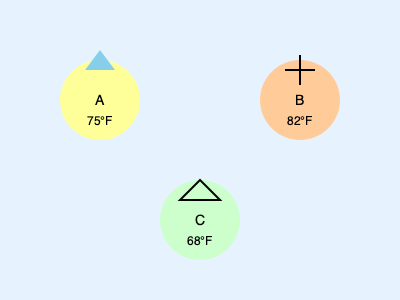Looking at this cheerful weather map, which city is most likely to have the perfect conditions for a sunny picnic with your fellow recruits? Let's break down the weather conditions for each city with a smile:

1. City A (100, 100):
   - Temperature: 75°F (quite pleasant!)
   - Weather icon: Raindrop shape (looks like it might rain)
   - Wind: No wind indicator

2. City B (300, 100):
   - Temperature: 82°F (getting a bit toasty)
   - Weather icon: Sun symbol (sunny and clear)
   - Wind: No wind indicator

3. City C (200, 220):
   - Temperature: 68°F (a bit cool, but still nice)
   - Weather icon: Wind direction arrow (pointing north)
   - Wind: Present, as indicated by the arrow

Now, let's think about the perfect picnic conditions:
- We want a warm, but not too hot temperature.
- Sunny skies are ideal for outdoor activities.
- Light wind or no wind is preferable to keep our picnic supplies from blowing away.

City B has the sunniest outlook with its clear sky icon and a warm temperature of 82°F. While it's a tad warmer than the others, it's still comfortable for outdoor activities. There's no indication of wind, which is great for keeping our picnic blanket and snacks in place.

City A, despite its pleasant 75°F temperature, shows a potential for rain, which could dampen our picnic spirits.

City C, while having a nice temperature of 68°F, shows wind presence, which might make it challenging to keep our picnic items secure.

Therefore, City B offers the most favorable conditions for a sunny and enjoyable picnic with your fellow recruits!
Answer: City B 